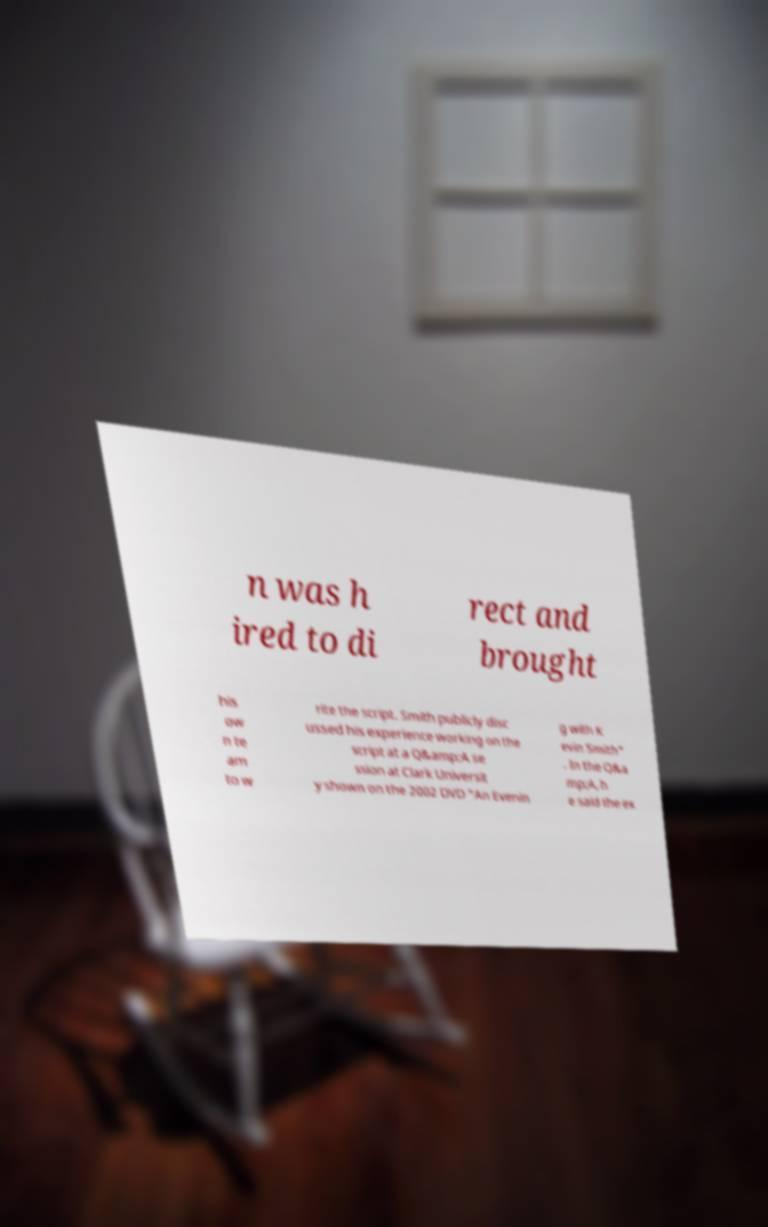What messages or text are displayed in this image? I need them in a readable, typed format. n was h ired to di rect and brought his ow n te am to w rite the script. Smith publicly disc ussed his experience working on the script at a Q&amp;A se ssion at Clark Universit y shown on the 2002 DVD "An Evenin g with K evin Smith" . In the Q&a mp;A, h e said the ex 